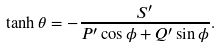<formula> <loc_0><loc_0><loc_500><loc_500>\tanh \theta = - \frac { S ^ { \prime } } { P ^ { \prime } \cos \phi + Q ^ { \prime } \sin \phi } .</formula> 